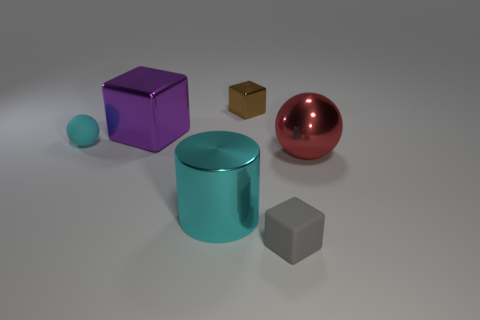Add 1 cyan matte objects. How many objects exist? 7 Subtract all purple cubes. How many cubes are left? 2 Subtract 1 blocks. How many blocks are left? 2 Subtract all spheres. How many objects are left? 4 Subtract all purple shiny objects. Subtract all cyan rubber blocks. How many objects are left? 5 Add 5 gray blocks. How many gray blocks are left? 6 Add 4 tiny blue metal things. How many tiny blue metal things exist? 4 Subtract 0 cyan blocks. How many objects are left? 6 